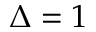<formula> <loc_0><loc_0><loc_500><loc_500>\Delta = 1</formula> 